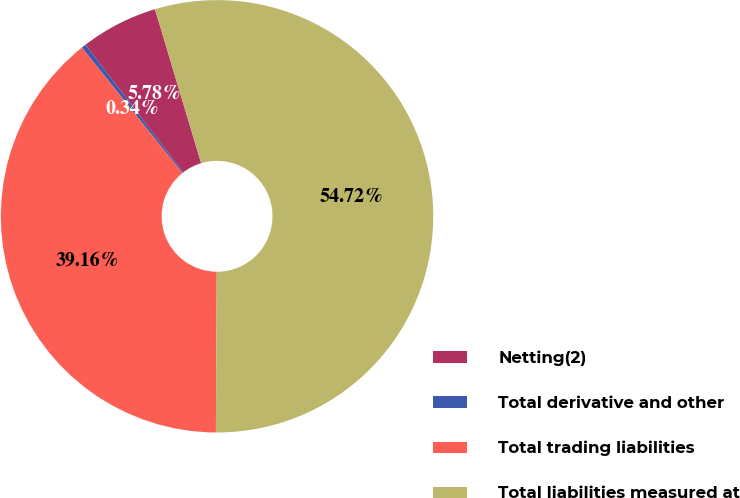<chart> <loc_0><loc_0><loc_500><loc_500><pie_chart><fcel>Netting(2)<fcel>Total derivative and other<fcel>Total trading liabilities<fcel>Total liabilities measured at<nl><fcel>5.78%<fcel>0.34%<fcel>39.16%<fcel>54.72%<nl></chart> 